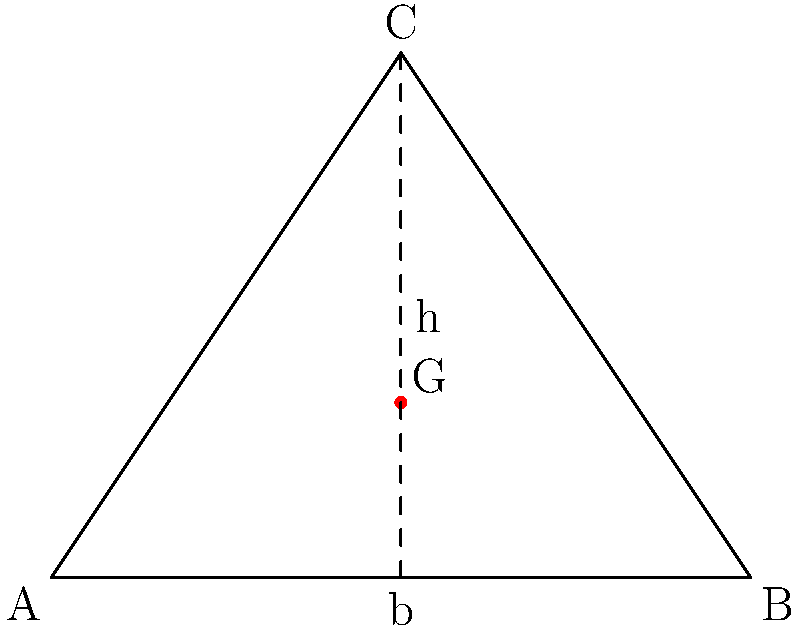Consider an ancient Egyptian pyramid modeled as a triangular cross-section with base length $b=4$ meters and height $h=3$ meters. Using postcolonial perspectives on the engineering achievements of ancient civilizations, analyze the location of the center of mass (G) for this structure. What fraction of the height from the base is the center of mass located? To find the center of mass of the triangular cross-section, we'll follow these steps:

1) In a uniform triangular shape, the center of mass is located at the intersection of the medians.

2) The medians divide each side into two equal parts, so the center of mass is located:
   - 1/3 of the way up from the base
   - 1/3 of the way in from each side

3) In this case, we're interested in the height fraction. The center of mass is located 1/3 of the total height from the base.

4) Mathematically, we can express this as:
   $$\text{Distance from base to G} = \frac{1}{3}h$$

5) To express this as a fraction of the height:
   $$\text{Fraction} = \frac{\text{Distance from base to G}}{\text{Total height}} = \frac{\frac{1}{3}h}{h} = \frac{1}{3}$$

This analysis showcases the advanced understanding of structural engineering in ancient civilizations, challenging Eurocentric narratives of technological progress.
Answer: $\frac{1}{3}$ 